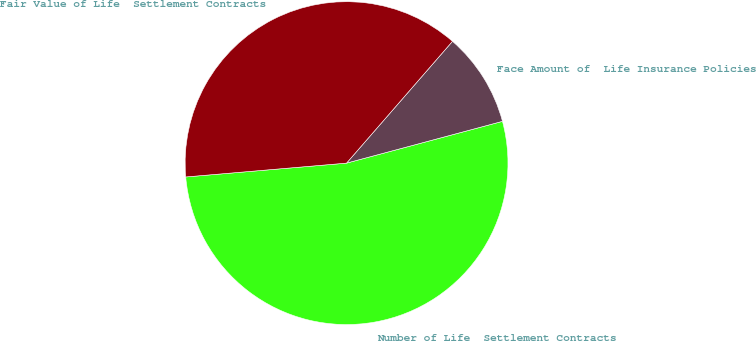Convert chart to OTSL. <chart><loc_0><loc_0><loc_500><loc_500><pie_chart><fcel>Number of Life  Settlement Contracts<fcel>Face Amount of  Life Insurance Policies<fcel>Fair Value of Life  Settlement Contracts<nl><fcel>52.8%<fcel>9.44%<fcel>37.76%<nl></chart> 